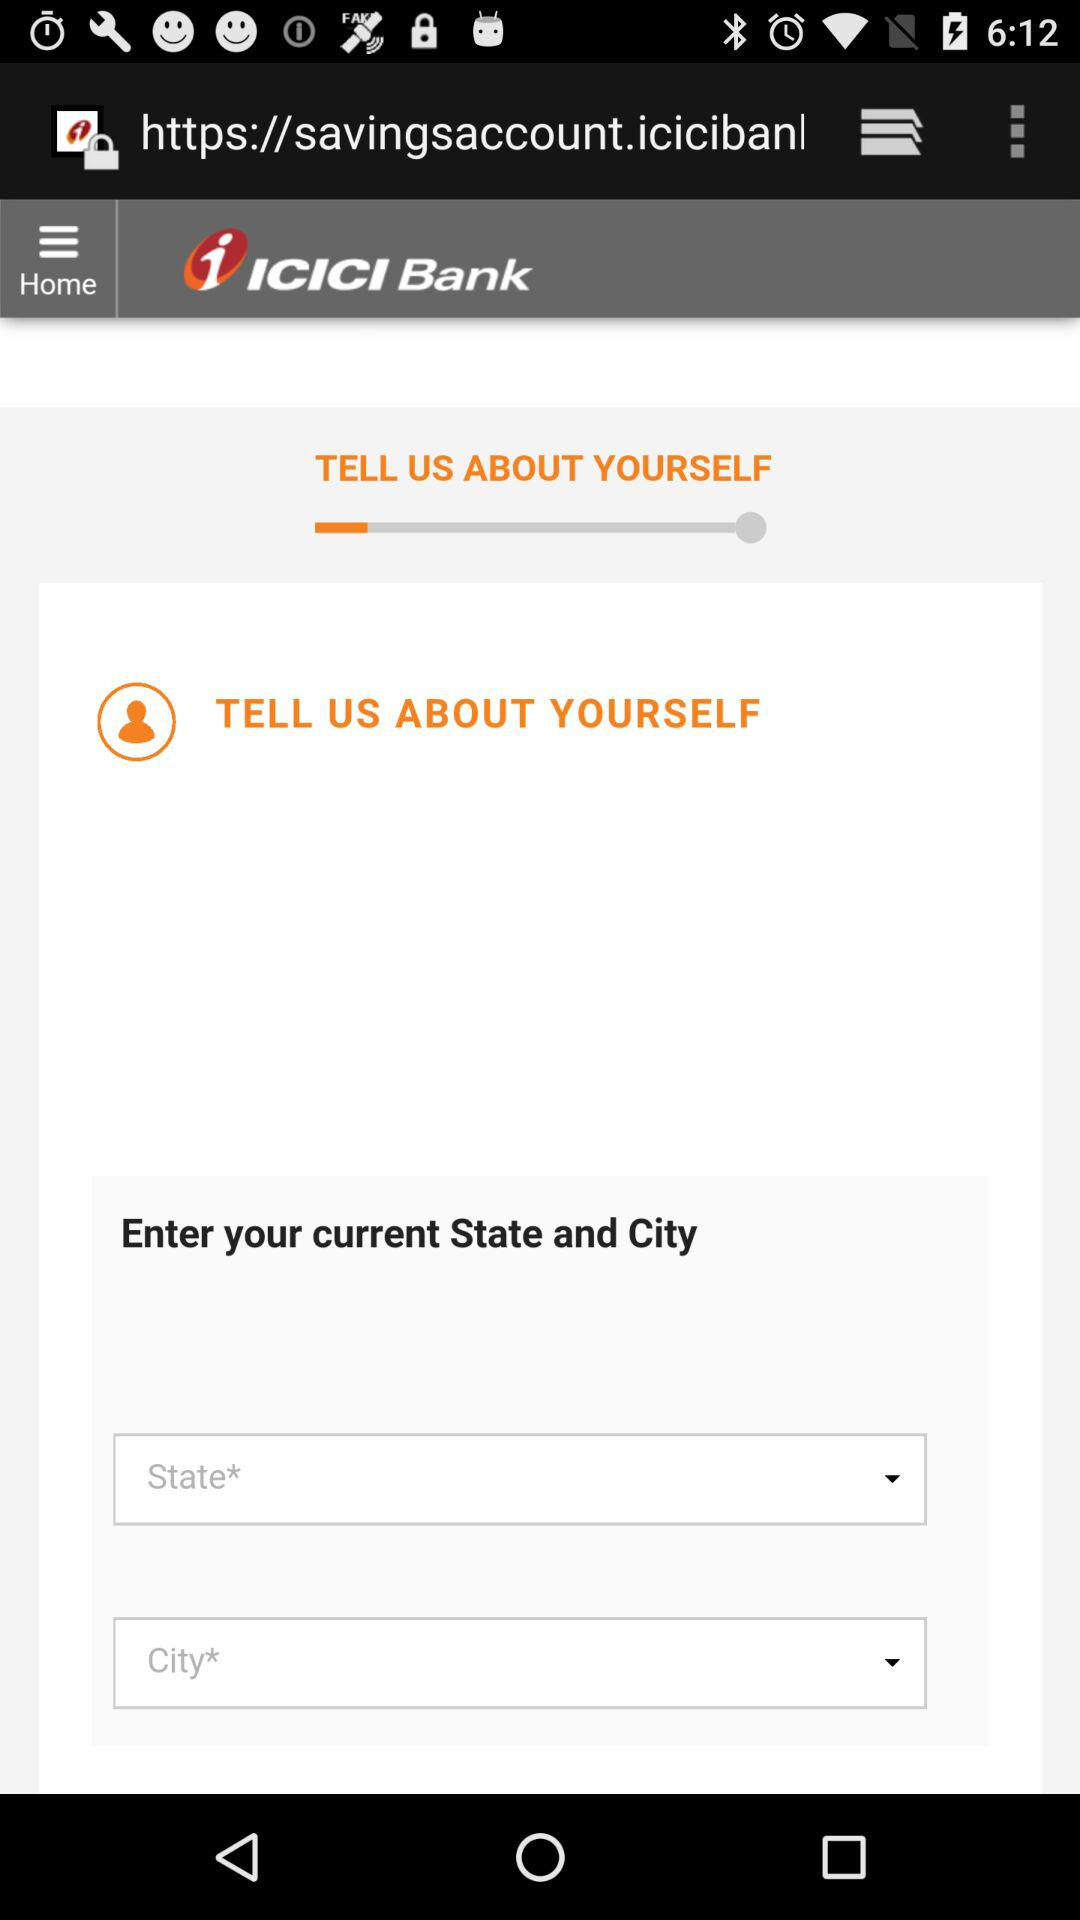What is the name of the application?
When the provided information is insufficient, respond with <no answer>. <no answer> 